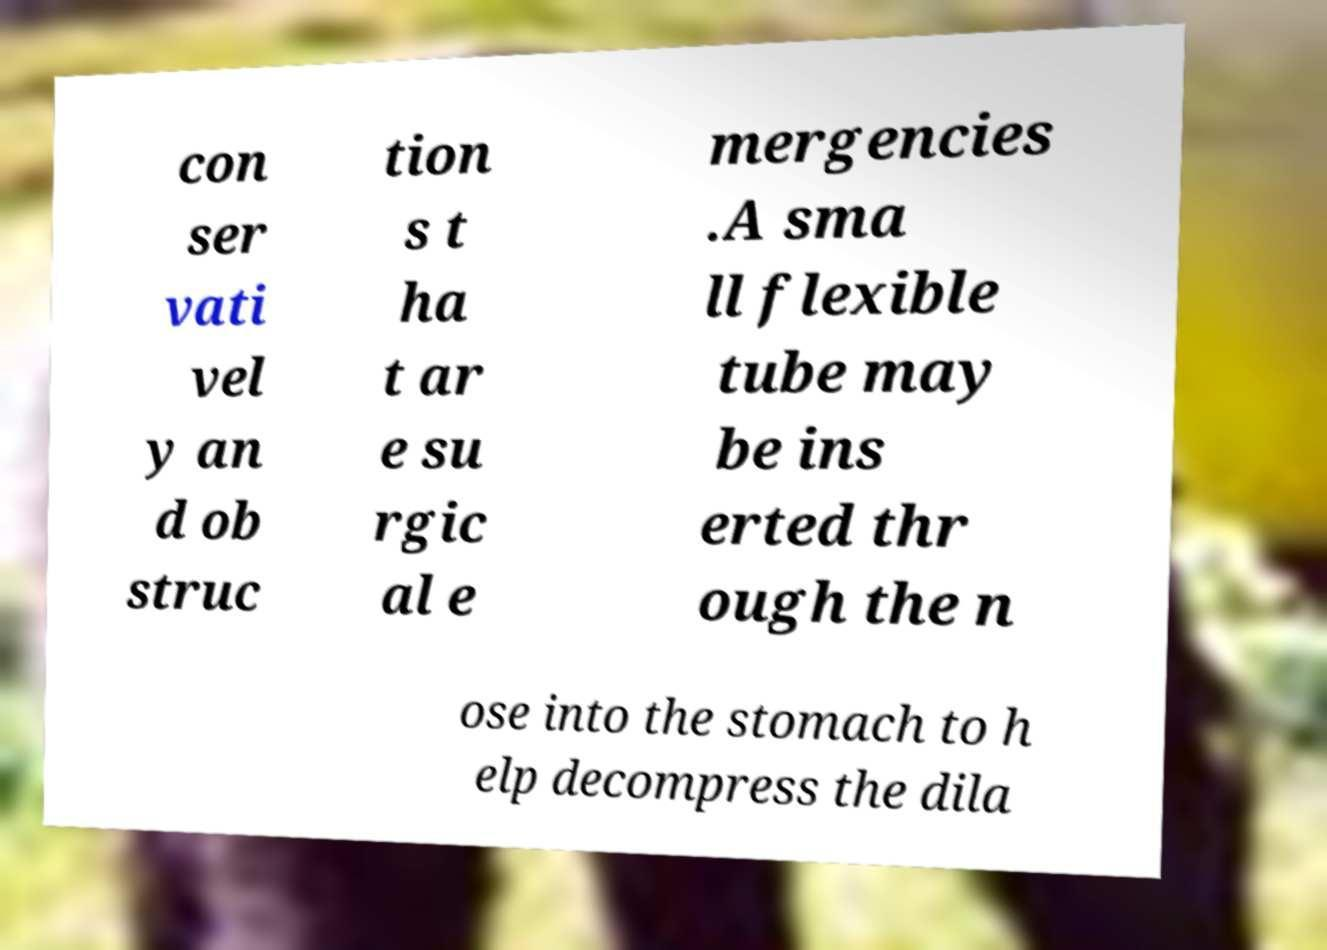Can you read and provide the text displayed in the image?This photo seems to have some interesting text. Can you extract and type it out for me? con ser vati vel y an d ob struc tion s t ha t ar e su rgic al e mergencies .A sma ll flexible tube may be ins erted thr ough the n ose into the stomach to h elp decompress the dila 